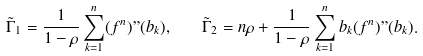<formula> <loc_0><loc_0><loc_500><loc_500>\tilde { \Gamma } _ { 1 } = \frac { 1 } { 1 - \rho } \sum _ { k = 1 } ^ { n } ( f ^ { n } ) " ( b _ { k } ) , \quad \tilde { \Gamma } _ { 2 } = n \rho + \frac { 1 } { 1 - \rho } \sum _ { k = 1 } ^ { n } b _ { k } ( f ^ { n } ) " ( b _ { k } ) .</formula> 